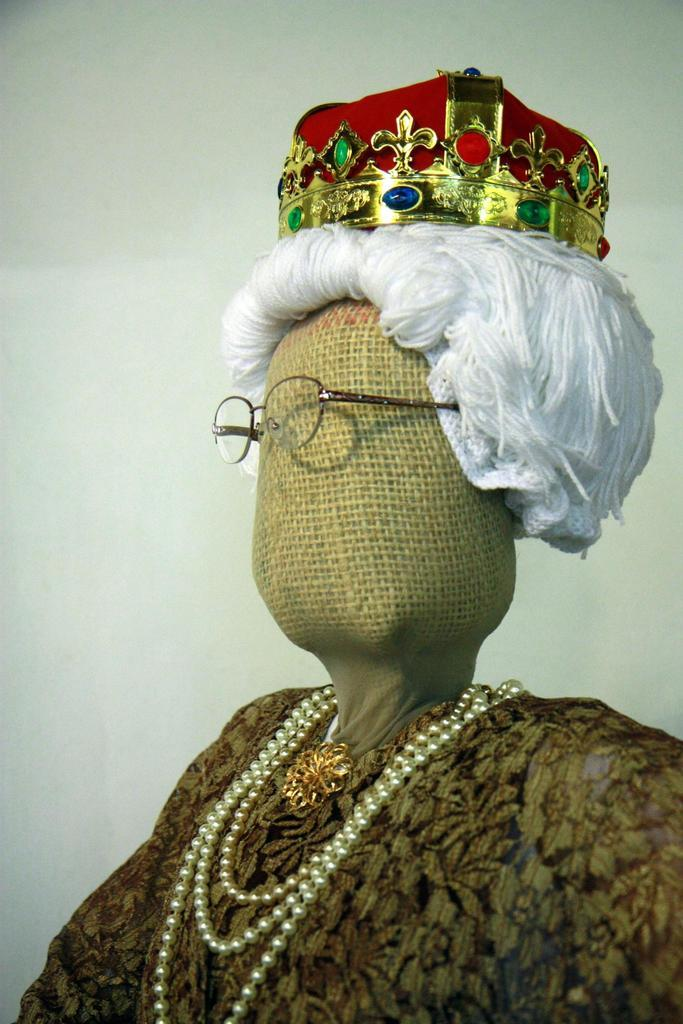What is the main subject of the image? The main subject of the image is a doll. What is the doll wearing on its head? The doll is wearing a crown. What type of accessory is the doll wearing on its face? The doll is wearing spectacles. What type of steel is used to construct the airplane in the image? There is no airplane present in the image; it only features a doll wearing a crown and spectacles. 